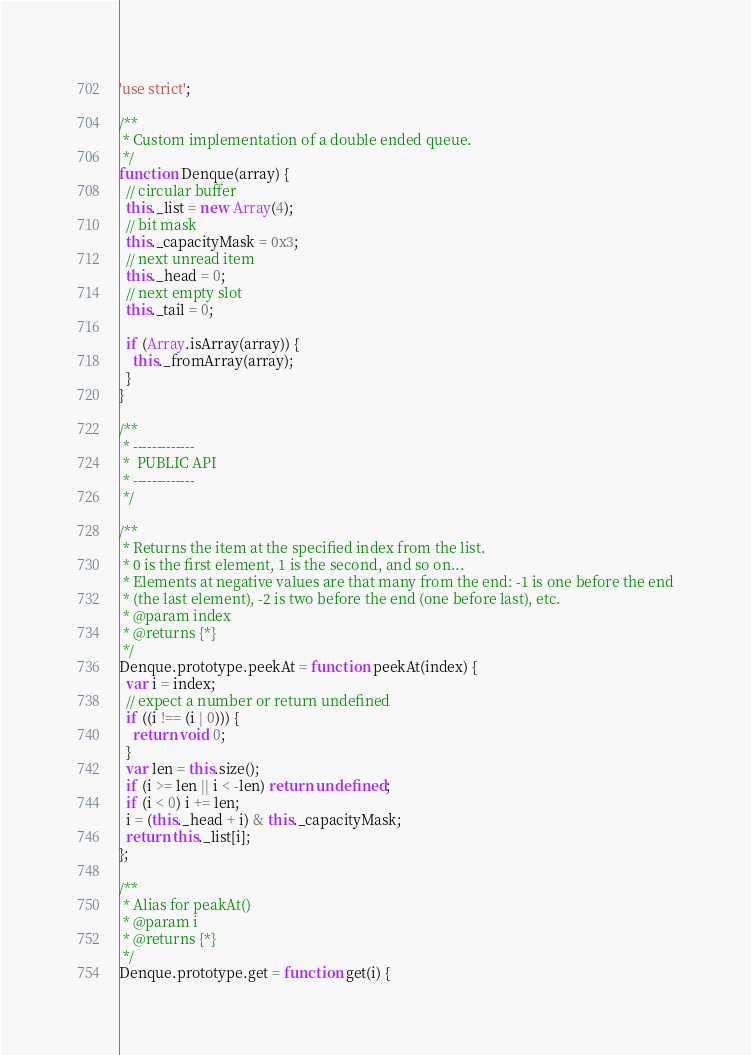Convert code to text. <code><loc_0><loc_0><loc_500><loc_500><_JavaScript_>'use strict';

/**
 * Custom implementation of a double ended queue.
 */
function Denque(array) {
  // circular buffer
  this._list = new Array(4);
  // bit mask
  this._capacityMask = 0x3;
  // next unread item
  this._head = 0;
  // next empty slot
  this._tail = 0;

  if (Array.isArray(array)) {
    this._fromArray(array);
  }
}

/**
 * -------------
 *  PUBLIC API
 * -------------
 */

/**
 * Returns the item at the specified index from the list.
 * 0 is the first element, 1 is the second, and so on...
 * Elements at negative values are that many from the end: -1 is one before the end
 * (the last element), -2 is two before the end (one before last), etc.
 * @param index
 * @returns {*}
 */
Denque.prototype.peekAt = function peekAt(index) {
  var i = index;
  // expect a number or return undefined
  if ((i !== (i | 0))) {
    return void 0;
  }
  var len = this.size();
  if (i >= len || i < -len) return undefined;
  if (i < 0) i += len;
  i = (this._head + i) & this._capacityMask;
  return this._list[i];
};

/**
 * Alias for peakAt()
 * @param i
 * @returns {*}
 */
Denque.prototype.get = function get(i) {</code> 